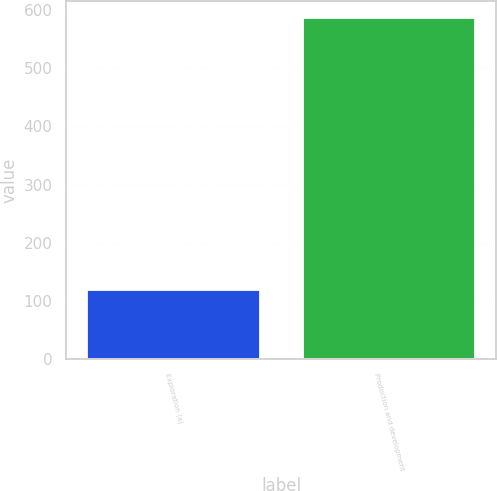Convert chart. <chart><loc_0><loc_0><loc_500><loc_500><bar_chart><fcel>Exploration (a)<fcel>Production and development<nl><fcel>119<fcel>586<nl></chart> 